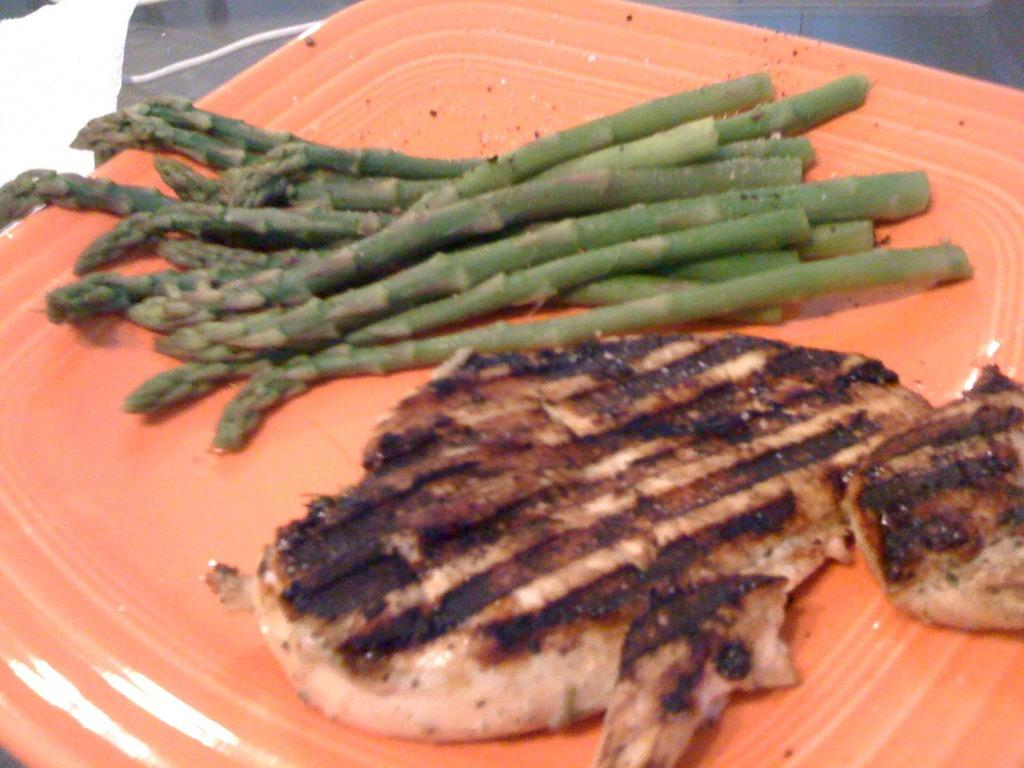What type of food item can be seen in the image? There is a food item in the image, specifically asparagus stems. How are the asparagus stems arranged in the image? The asparagus stems are placed on a tray in the image. What type of soda is being served in the room in the image? There is no soda or room present in the image; it only features asparagus stems placed on a tray. 